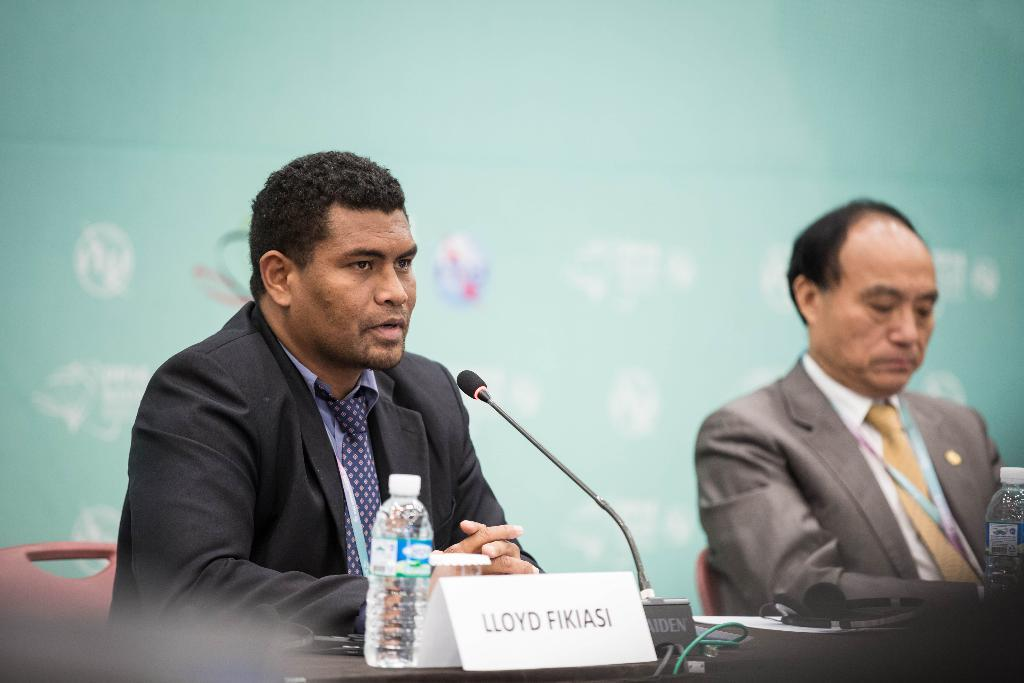How many people are sitting in the image? There are two persons sitting on chairs in the image. What is present on the table in the image? There are bottles, a microphone (mic), a name board, and other items on the table in the image. What can be seen in the background of the image? There is a wall in the background of the image. What type of ball is being used to sort the items on the table? There is no ball or sorting activity present in the image. Can you see a snake slithering on the wall in the background? There is no snake visible in the image; only a wall can be seen in the background. 